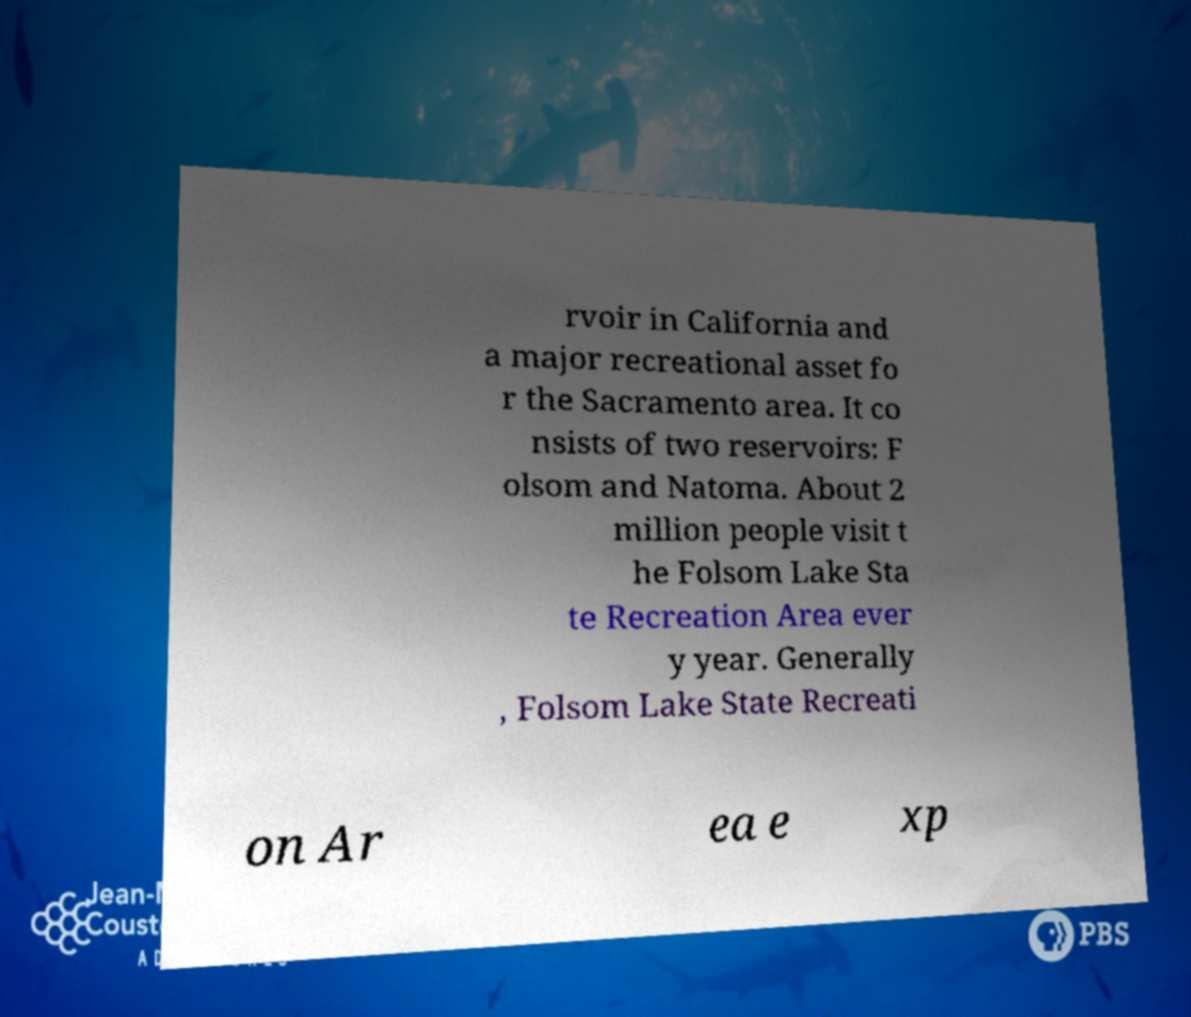There's text embedded in this image that I need extracted. Can you transcribe it verbatim? rvoir in California and a major recreational asset fo r the Sacramento area. It co nsists of two reservoirs: F olsom and Natoma. About 2 million people visit t he Folsom Lake Sta te Recreation Area ever y year. Generally , Folsom Lake State Recreati on Ar ea e xp 